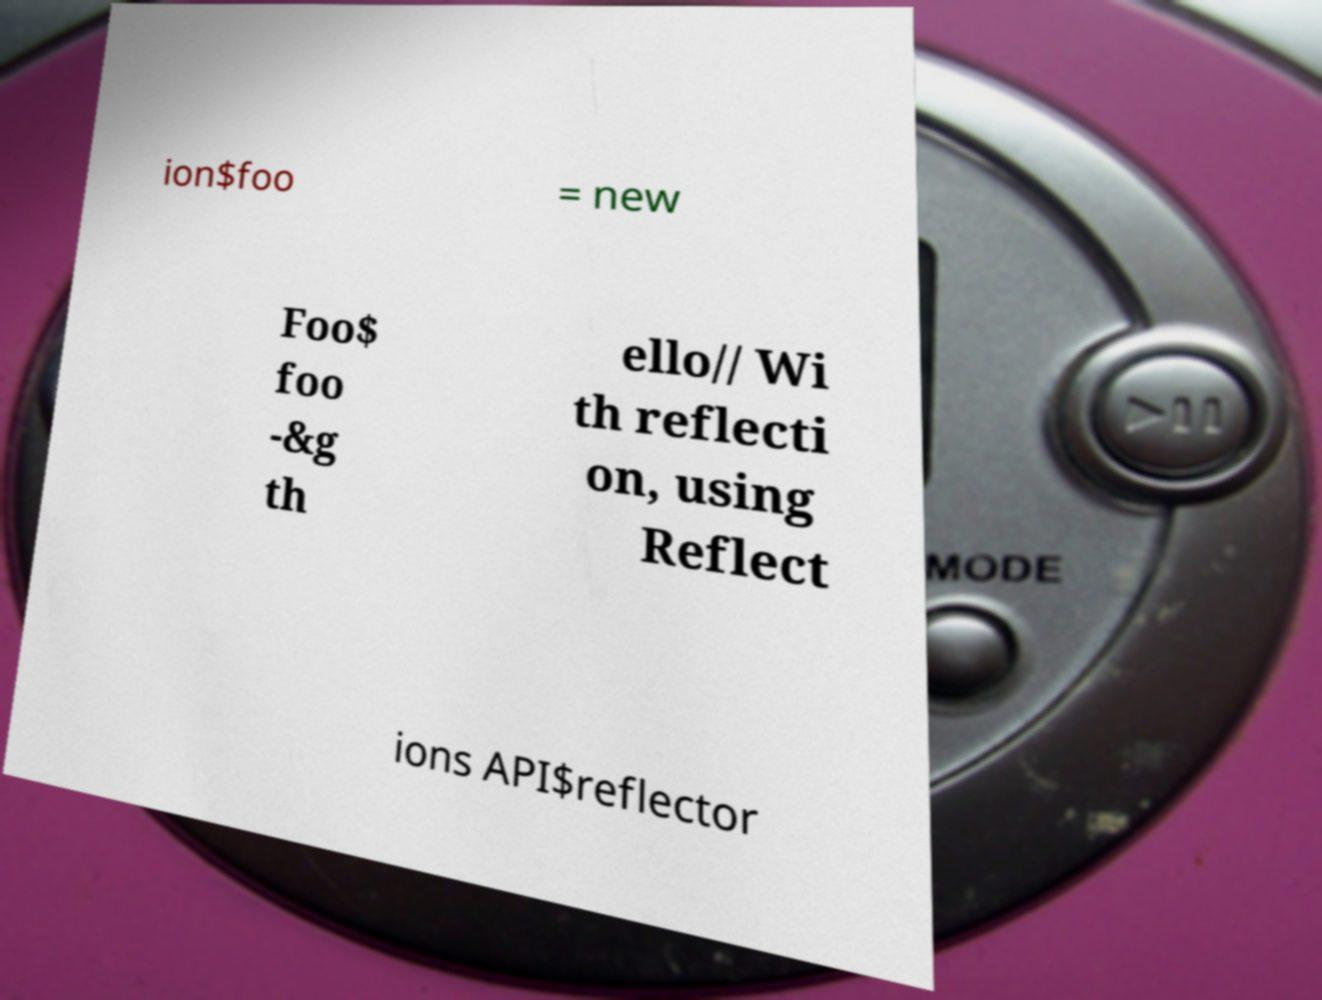Could you assist in decoding the text presented in this image and type it out clearly? ion$foo = new Foo$ foo -&g th ello// Wi th reflecti on, using Reflect ions API$reflector 